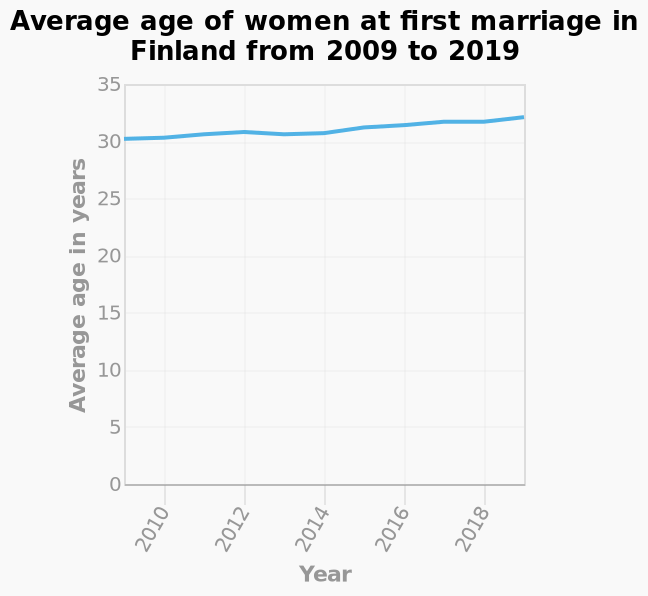<image>
What is the name of the line graph? The line graph is named Average age of women at first marriage in Finland from 2009 to 2019. What is the subject of the line graph? The line graph represents the average age of women at first marriage in Finland. Describe the following image in detail This line graph is named Average age of women at first marriage in Finland from 2009 to 2019. Year is measured along the x-axis. Average age in years is drawn on the y-axis. What was the average age of marriage for women in Finland in 2010?  The average age of marriage for women in Finland was just over 30 in 2010. 